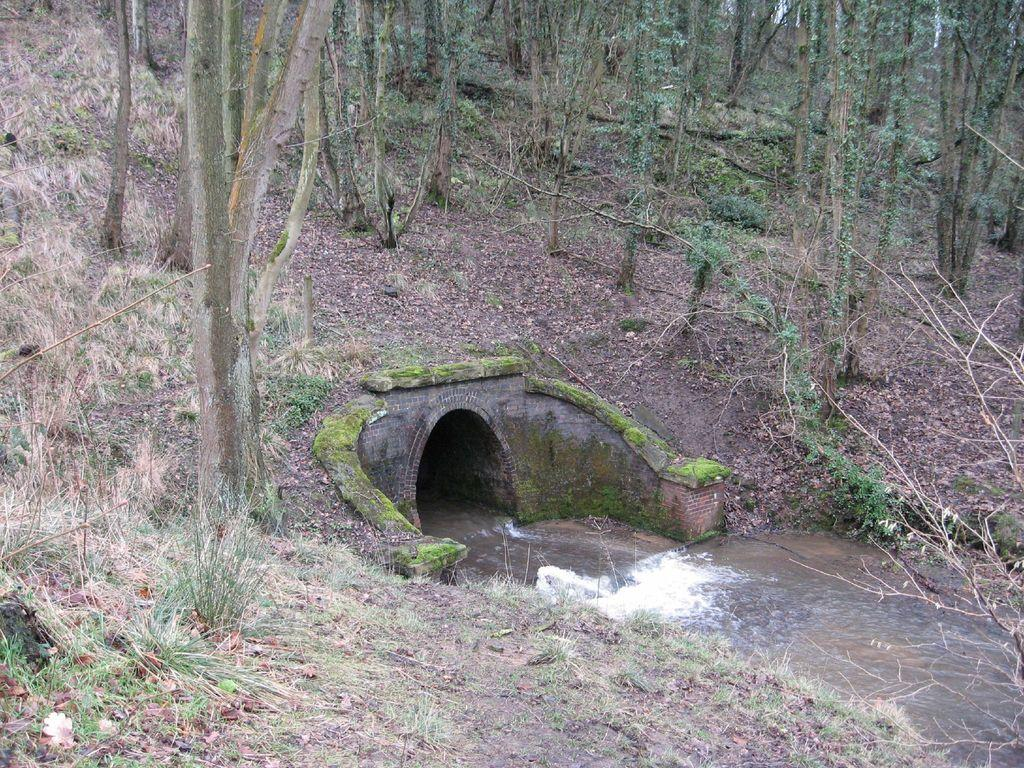What is the main feature in the center of the image? There is a water tunnel at the center of the image. What type of vegetation is present at the bottom of the image? There is grass on the surface at the bottom of the image. What can be seen in the background of the image? There are trees in the background of the image. How many beads are hanging from the trees in the image? There are no beads present in the image; it features a water tunnel, grass, and trees. What type of finger can be seen interacting with the water tunnel in the image? There are no fingers present in the image; it only features a water tunnel, grass, and trees. 